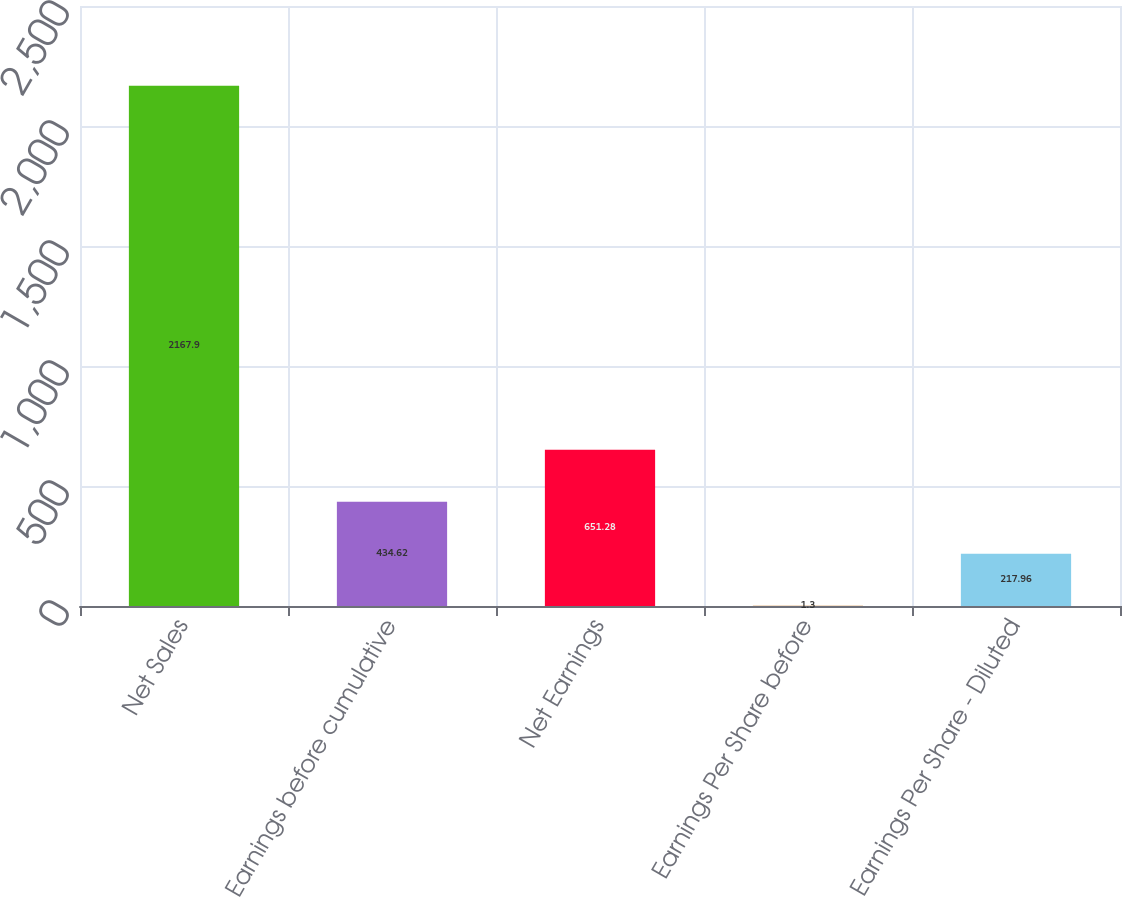<chart> <loc_0><loc_0><loc_500><loc_500><bar_chart><fcel>Net Sales<fcel>Earnings before cumulative<fcel>Net Earnings<fcel>Earnings Per Share before<fcel>Earnings Per Share - Diluted<nl><fcel>2167.9<fcel>434.62<fcel>651.28<fcel>1.3<fcel>217.96<nl></chart> 